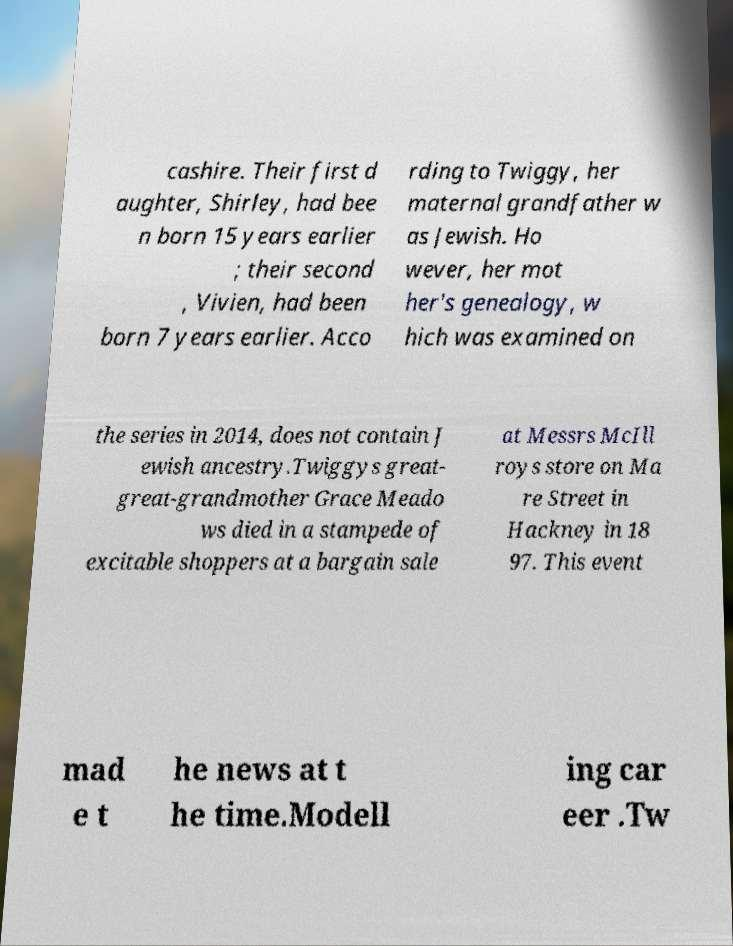Could you extract and type out the text from this image? cashire. Their first d aughter, Shirley, had bee n born 15 years earlier ; their second , Vivien, had been born 7 years earlier. Acco rding to Twiggy, her maternal grandfather w as Jewish. Ho wever, her mot her's genealogy, w hich was examined on the series in 2014, does not contain J ewish ancestry.Twiggys great- great-grandmother Grace Meado ws died in a stampede of excitable shoppers at a bargain sale at Messrs McIll roys store on Ma re Street in Hackney in 18 97. This event mad e t he news at t he time.Modell ing car eer .Tw 